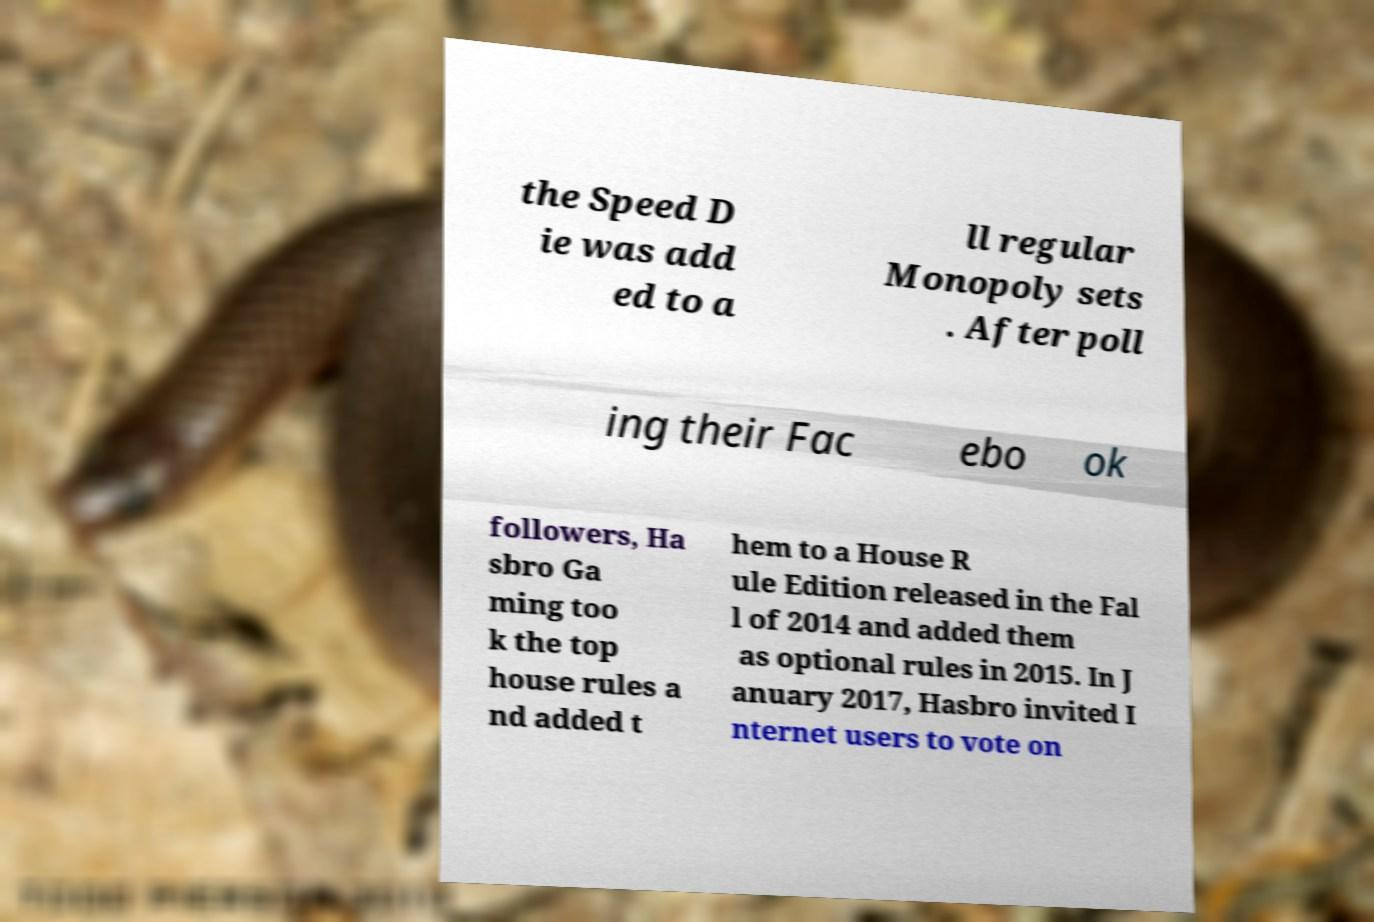Can you accurately transcribe the text from the provided image for me? the Speed D ie was add ed to a ll regular Monopoly sets . After poll ing their Fac ebo ok followers, Ha sbro Ga ming too k the top house rules a nd added t hem to a House R ule Edition released in the Fal l of 2014 and added them as optional rules in 2015. In J anuary 2017, Hasbro invited I nternet users to vote on 